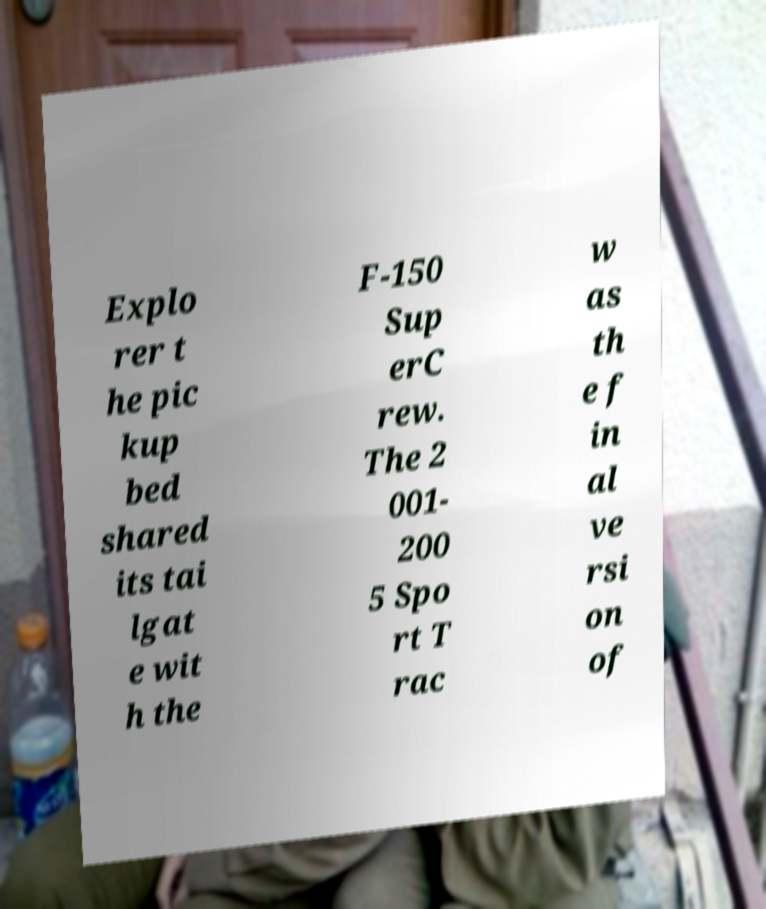Can you read and provide the text displayed in the image?This photo seems to have some interesting text. Can you extract and type it out for me? Explo rer t he pic kup bed shared its tai lgat e wit h the F-150 Sup erC rew. The 2 001- 200 5 Spo rt T rac w as th e f in al ve rsi on of 